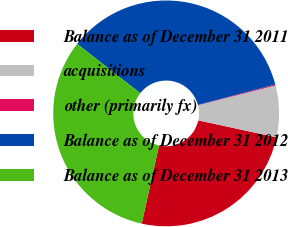Convert chart. <chart><loc_0><loc_0><loc_500><loc_500><pie_chart><fcel>Balance as of December 31 2011<fcel>acquisitions<fcel>other (primarily fx)<fcel>Balance as of December 31 2012<fcel>Balance as of December 31 2013<nl><fcel>25.08%<fcel>7.38%<fcel>0.14%<fcel>35.33%<fcel>32.07%<nl></chart> 